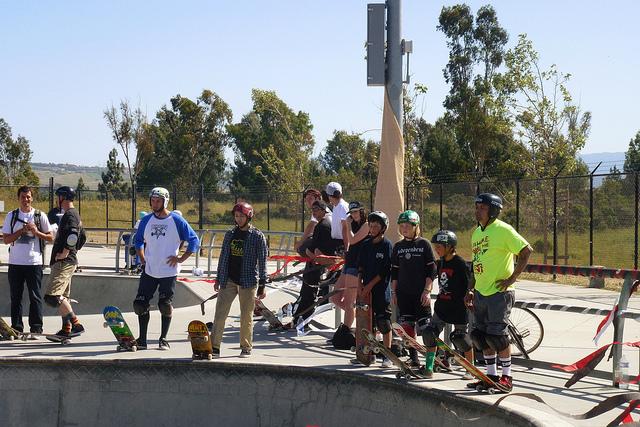What are the boys holding with their feet?
Quick response, please. Skateboards. Are the boys happy?
Answer briefly. Yes. Is it raining?
Give a very brief answer. No. Is the skater airborne?
Answer briefly. No. Is the skateboarder wearing a baseball cap or a helmet?
Answer briefly. Helmet. 